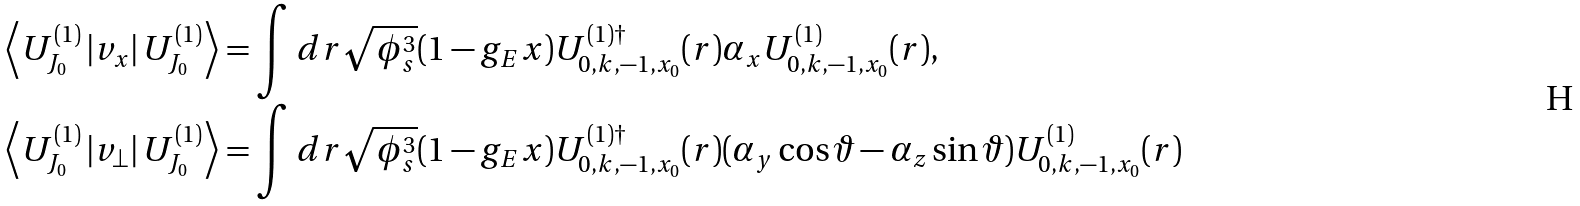Convert formula to latex. <formula><loc_0><loc_0><loc_500><loc_500>\left \langle U ^ { ( 1 ) } _ { J _ { 0 } } \left | v _ { x } \right | U ^ { ( 1 ) } _ { J _ { 0 } } \right \rangle & = \int d r \sqrt { \phi _ { s } ^ { 3 } } ( 1 - g _ { E } x ) U ^ { ( 1 ) \dag } _ { 0 , k , - 1 , x _ { 0 } } ( r ) \alpha _ { x } U ^ { ( 1 ) } _ { 0 , k , - 1 , x _ { 0 } } ( r ) , \\ \left \langle U ^ { ( 1 ) } _ { J _ { 0 } } \left | v _ { \perp } \right | U ^ { ( 1 ) } _ { J _ { 0 } } \right \rangle & = \int d r \sqrt { \phi _ { s } ^ { 3 } } ( 1 - g _ { E } x ) U ^ { ( 1 ) \dag } _ { 0 , k , - 1 , x _ { 0 } } ( r ) ( \alpha _ { y } \cos \vartheta - \alpha _ { z } \sin \vartheta ) U ^ { ( 1 ) } _ { 0 , k , - 1 , x _ { 0 } } ( r )</formula> 